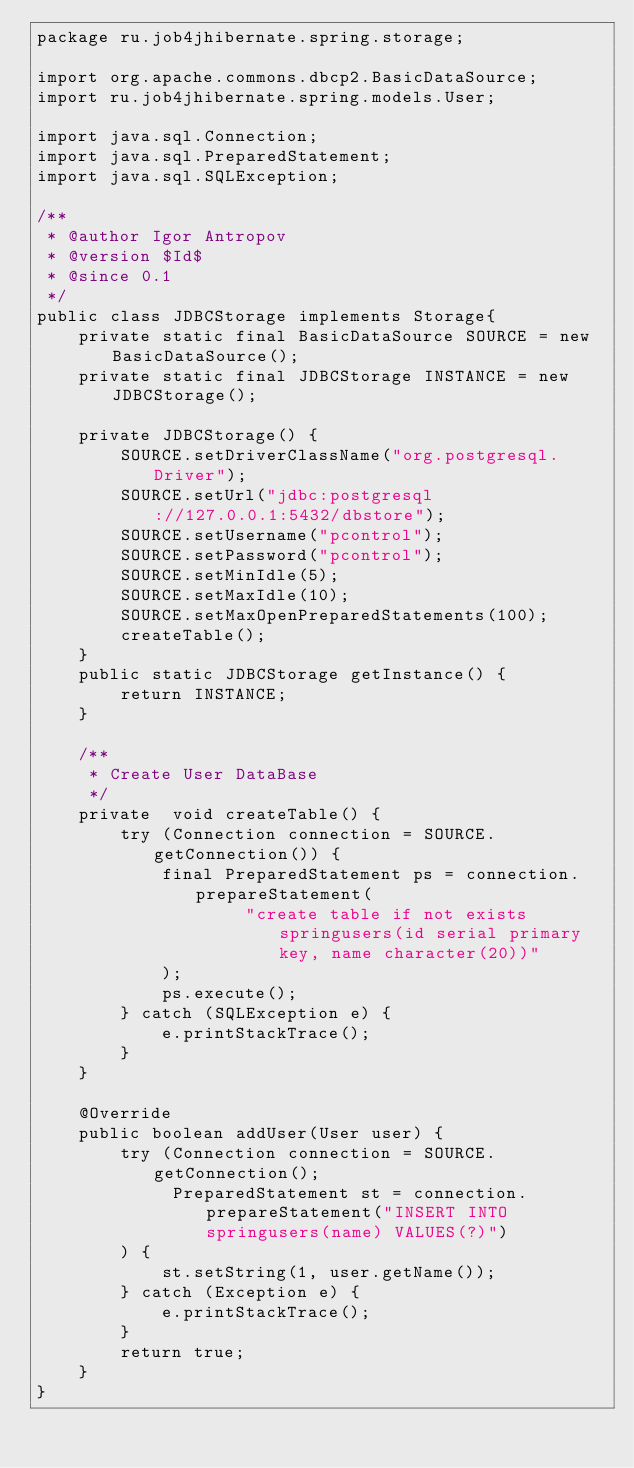<code> <loc_0><loc_0><loc_500><loc_500><_Java_>package ru.job4jhibernate.spring.storage;

import org.apache.commons.dbcp2.BasicDataSource;
import ru.job4jhibernate.spring.models.User;

import java.sql.Connection;
import java.sql.PreparedStatement;
import java.sql.SQLException;

/**
 * @author Igor Antropov
 * @version $Id$
 * @since 0.1
 */
public class JDBCStorage implements Storage{
    private static final BasicDataSource SOURCE = new BasicDataSource();
    private static final JDBCStorage INSTANCE = new JDBCStorage();

    private JDBCStorage() {
        SOURCE.setDriverClassName("org.postgresql.Driver");
        SOURCE.setUrl("jdbc:postgresql://127.0.0.1:5432/dbstore");
        SOURCE.setUsername("pcontrol");
        SOURCE.setPassword("pcontrol");
        SOURCE.setMinIdle(5);
        SOURCE.setMaxIdle(10);
        SOURCE.setMaxOpenPreparedStatements(100);
        createTable();
    }
    public static JDBCStorage getInstance() {
        return INSTANCE;
    }

    /**
     * Create User DataBase
     */
    private  void createTable() {
        try (Connection connection = SOURCE.getConnection()) {
            final PreparedStatement ps = connection.prepareStatement(
                    "create table if not exists springusers(id serial primary key, name character(20))"
            );
            ps.execute();
        } catch (SQLException e) {
            e.printStackTrace();
        }
    }

    @Override
    public boolean addUser(User user) {
        try (Connection connection = SOURCE.getConnection();
             PreparedStatement st = connection.prepareStatement("INSERT INTO springusers(name) VALUES(?)")
        ) {
            st.setString(1, user.getName());
        } catch (Exception e) {
            e.printStackTrace();
        }
        return true;
    }
}
</code> 